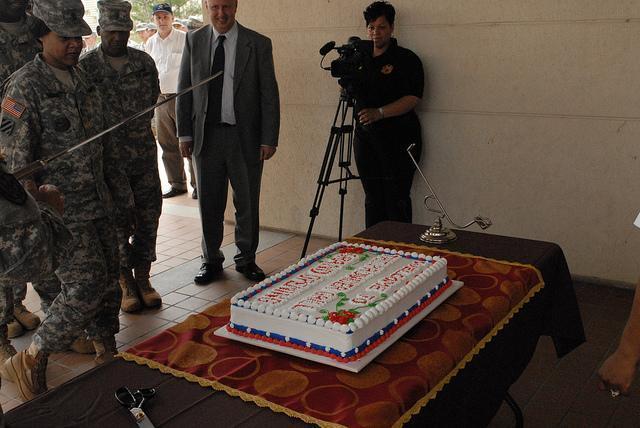How many people are cutting the cake?
Give a very brief answer. 0. How many people are there?
Give a very brief answer. 6. 